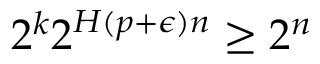<formula> <loc_0><loc_0><loc_500><loc_500>2 ^ { k } 2 ^ { H ( p + \epsilon ) n } \geq 2 ^ { n }</formula> 